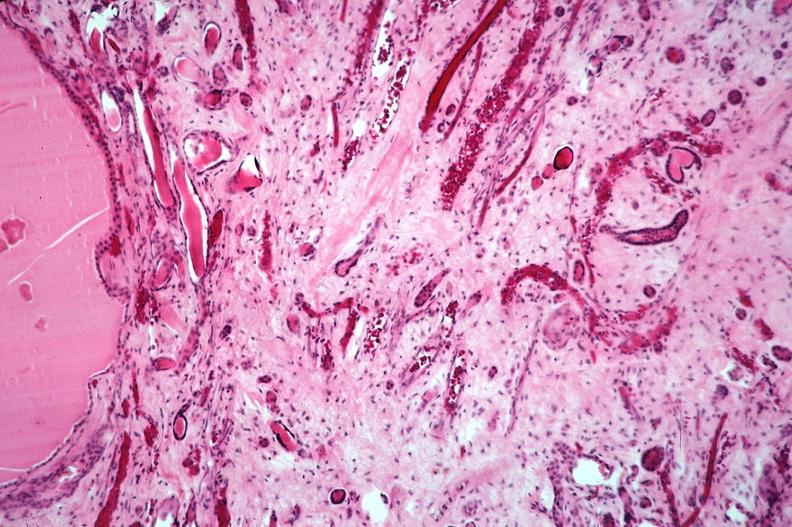does this image show kidney, adult polycystic kidney?
Answer the question using a single word or phrase. Yes 